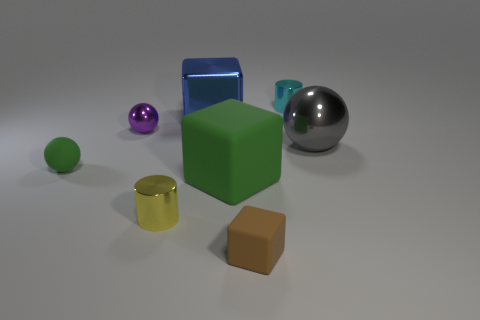There is a small cylinder that is on the left side of the tiny cyan metallic cylinder; is its color the same as the big block that is behind the tiny purple shiny sphere?
Your answer should be very brief. No. There is a brown block; are there any gray objects to the left of it?
Offer a very short reply. No. What is the material of the brown block?
Offer a very short reply. Rubber. The rubber object that is left of the purple shiny ball has what shape?
Keep it short and to the point. Sphere. What is the size of the rubber ball that is the same color as the big rubber block?
Offer a very short reply. Small. Is there a red cylinder that has the same size as the cyan metallic thing?
Offer a terse response. No. Are the green thing that is on the right side of the metal cube and the purple object made of the same material?
Keep it short and to the point. No. Is the number of tiny cyan cylinders that are on the left side of the big green rubber object the same as the number of tiny shiny objects that are on the left side of the big blue object?
Make the answer very short. No. There is a small thing that is behind the gray thing and to the left of the tiny cyan cylinder; what is its shape?
Your response must be concise. Sphere. There is a green rubber ball; how many small green spheres are on the left side of it?
Make the answer very short. 0. 